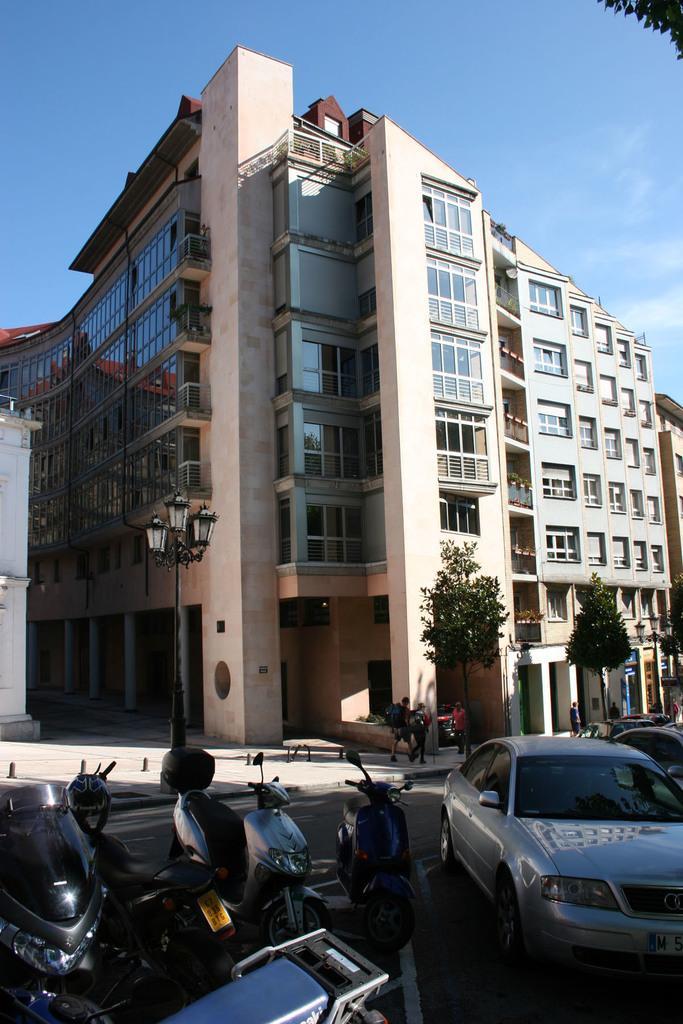Please provide a concise description of this image. At the bottom of the image we can see some motorcycles and cars on the road. Behind them few people are walking and there are some trees and poles. Behind the trees we can see some buildings. At the top of the image we can see some clouds in the sky. 